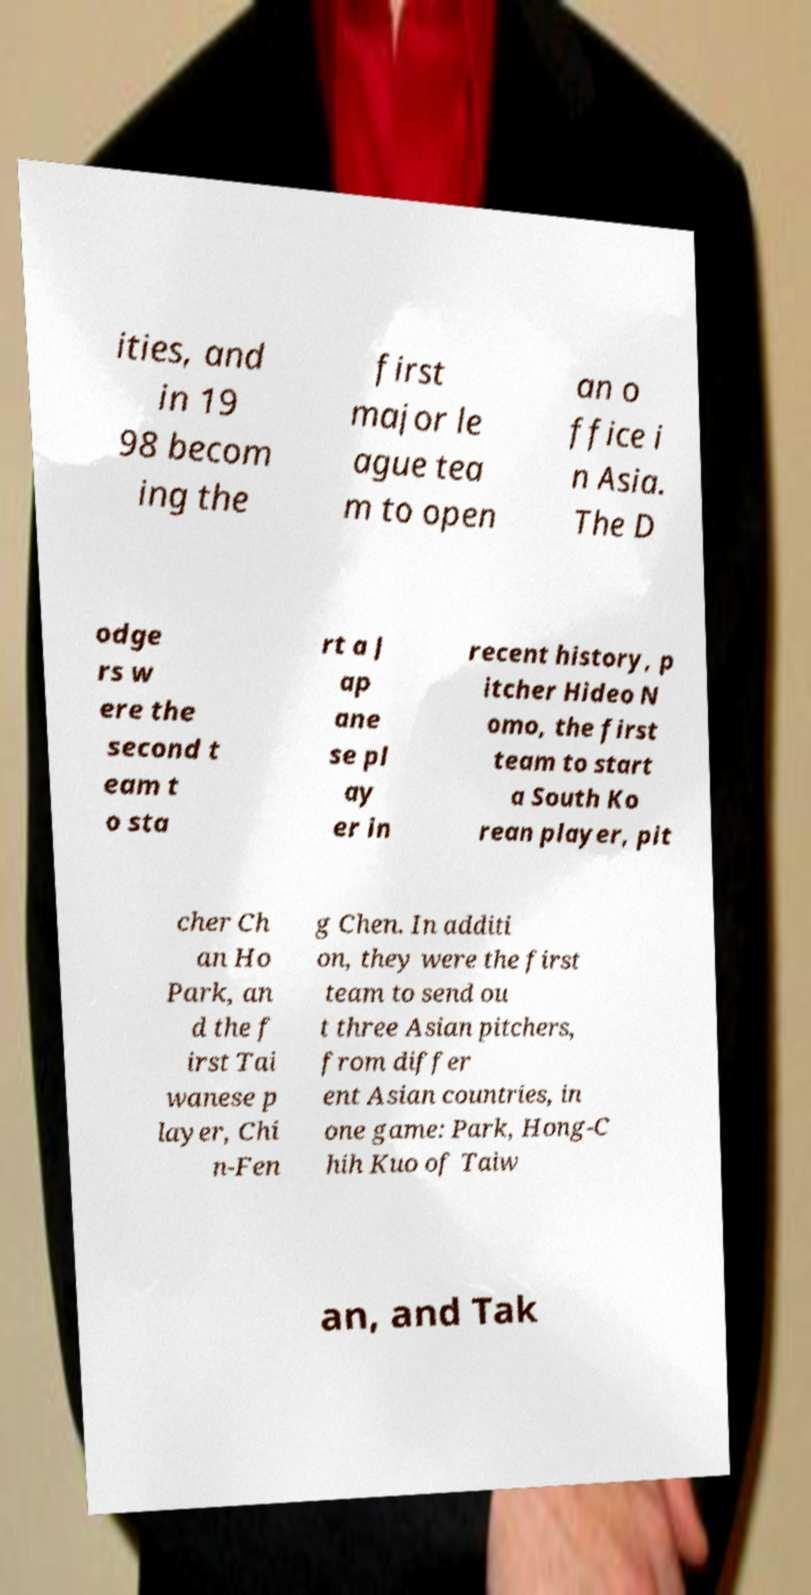For documentation purposes, I need the text within this image transcribed. Could you provide that? ities, and in 19 98 becom ing the first major le ague tea m to open an o ffice i n Asia. The D odge rs w ere the second t eam t o sta rt a J ap ane se pl ay er in recent history, p itcher Hideo N omo, the first team to start a South Ko rean player, pit cher Ch an Ho Park, an d the f irst Tai wanese p layer, Chi n-Fen g Chen. In additi on, they were the first team to send ou t three Asian pitchers, from differ ent Asian countries, in one game: Park, Hong-C hih Kuo of Taiw an, and Tak 